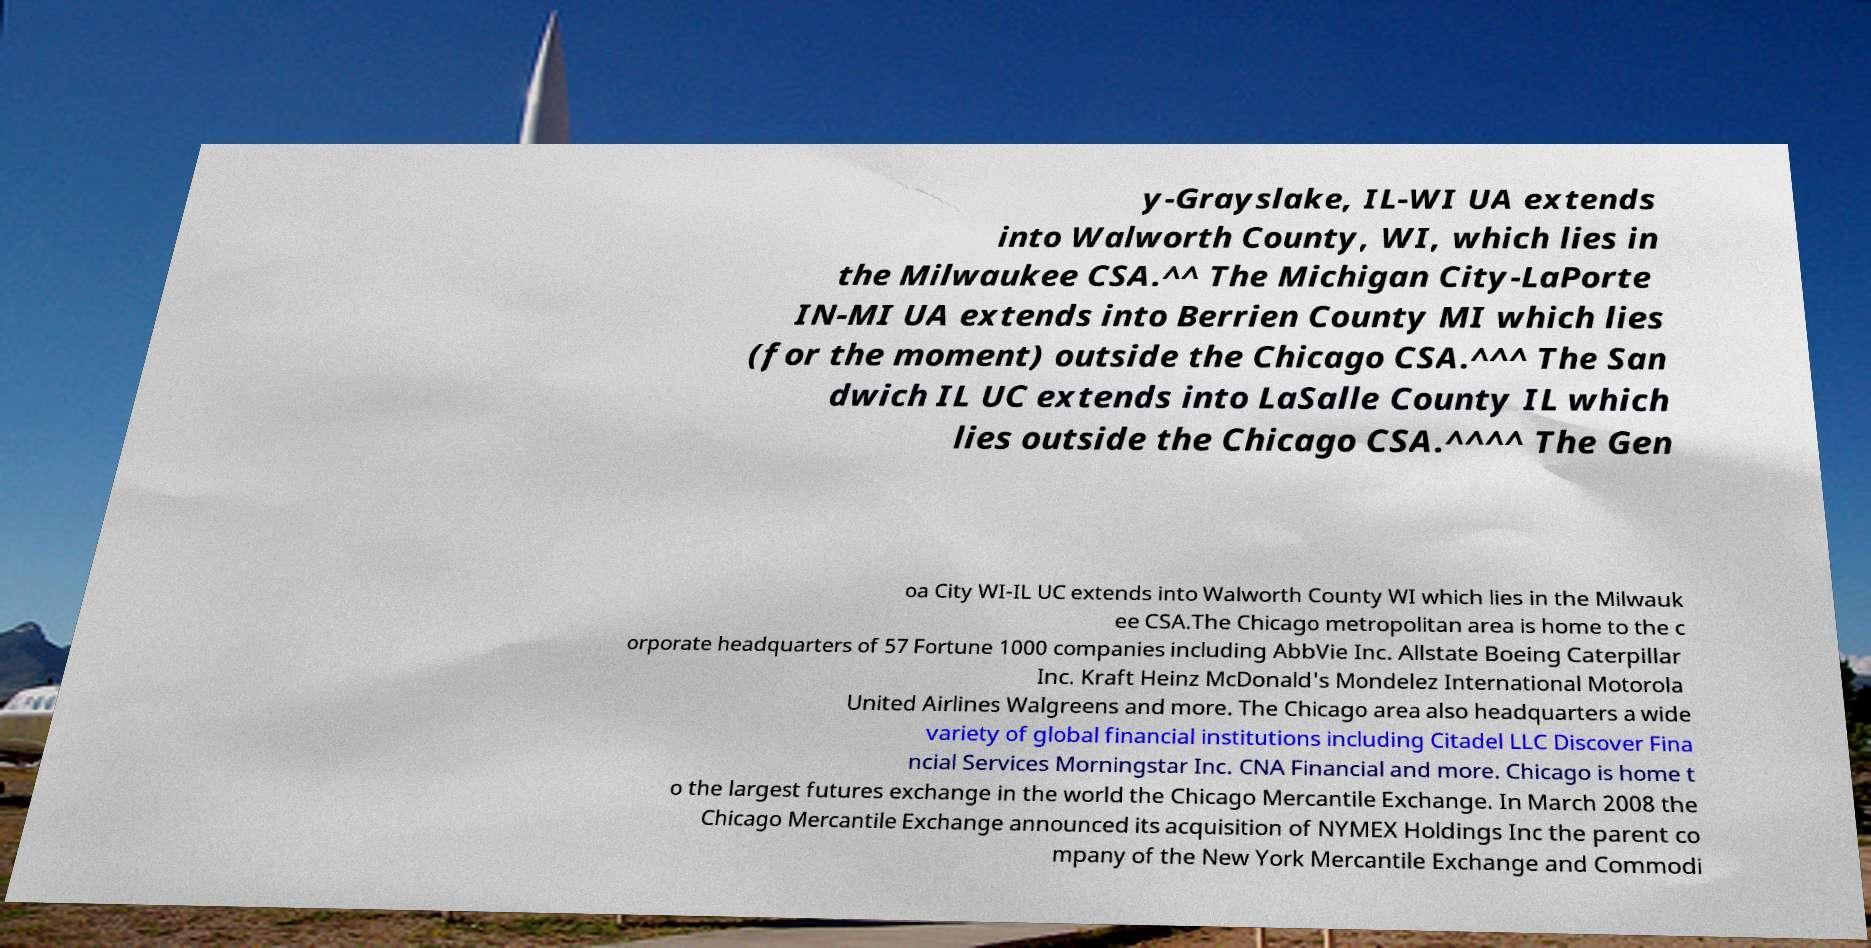For documentation purposes, I need the text within this image transcribed. Could you provide that? y-Grayslake, IL-WI UA extends into Walworth County, WI, which lies in the Milwaukee CSA.^^ The Michigan City-LaPorte IN-MI UA extends into Berrien County MI which lies (for the moment) outside the Chicago CSA.^^^ The San dwich IL UC extends into LaSalle County IL which lies outside the Chicago CSA.^^^^ The Gen oa City WI-IL UC extends into Walworth County WI which lies in the Milwauk ee CSA.The Chicago metropolitan area is home to the c orporate headquarters of 57 Fortune 1000 companies including AbbVie Inc. Allstate Boeing Caterpillar Inc. Kraft Heinz McDonald's Mondelez International Motorola United Airlines Walgreens and more. The Chicago area also headquarters a wide variety of global financial institutions including Citadel LLC Discover Fina ncial Services Morningstar Inc. CNA Financial and more. Chicago is home t o the largest futures exchange in the world the Chicago Mercantile Exchange. In March 2008 the Chicago Mercantile Exchange announced its acquisition of NYMEX Holdings Inc the parent co mpany of the New York Mercantile Exchange and Commodi 